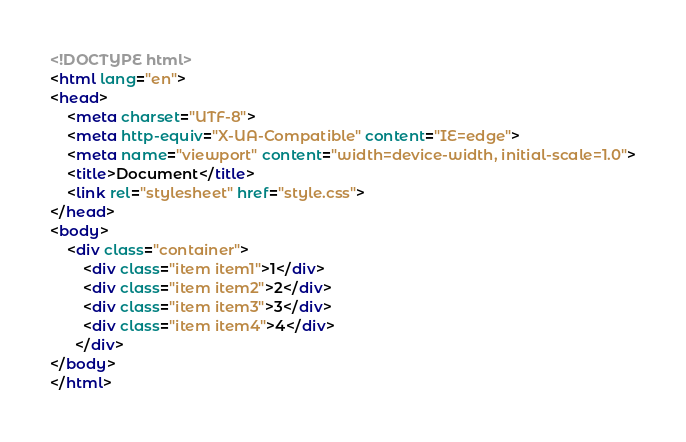Convert code to text. <code><loc_0><loc_0><loc_500><loc_500><_HTML_><!DOCTYPE html>
<html lang="en">
<head>
    <meta charset="UTF-8">
    <meta http-equiv="X-UA-Compatible" content="IE=edge">
    <meta name="viewport" content="width=device-width, initial-scale=1.0">
    <title>Document</title>
    <link rel="stylesheet" href="style.css">
</head>
<body>
    <div class="container">
        <div class="item item1">1</div>
        <div class="item item2">2</div>
        <div class="item item3">3</div>
        <div class="item item4">4</div>
      </div>
</body>
</html></code> 